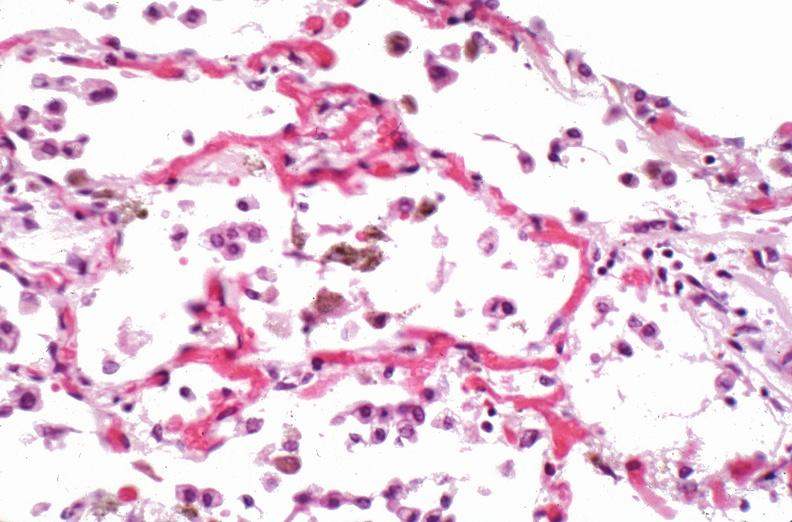where is this?
Answer the question using a single word or phrase. Lung 